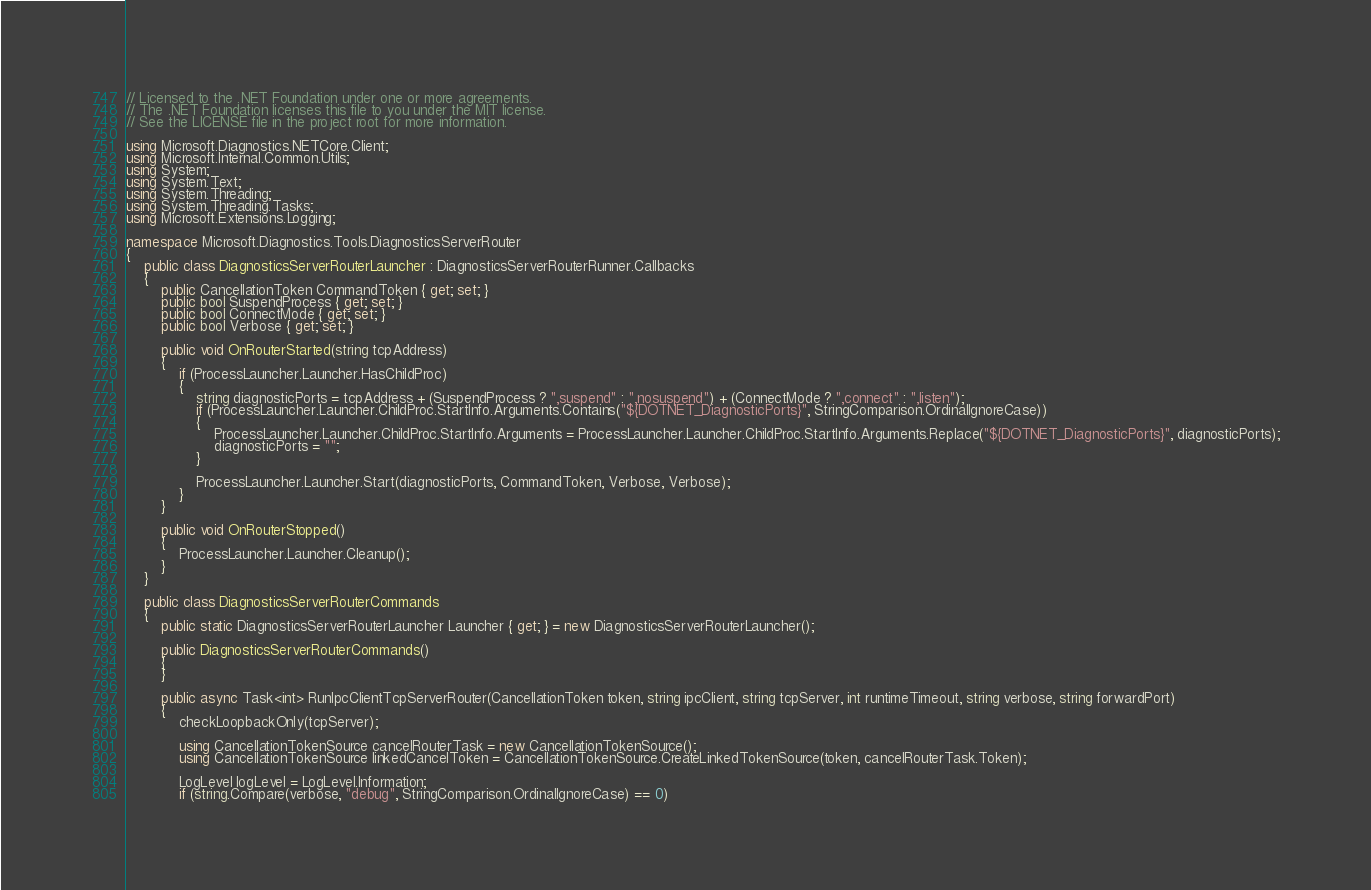<code> <loc_0><loc_0><loc_500><loc_500><_C#_>// Licensed to the .NET Foundation under one or more agreements.
// The .NET Foundation licenses this file to you under the MIT license.
// See the LICENSE file in the project root for more information.

using Microsoft.Diagnostics.NETCore.Client;
using Microsoft.Internal.Common.Utils;
using System;
using System.Text;
using System.Threading;
using System.Threading.Tasks;
using Microsoft.Extensions.Logging;

namespace Microsoft.Diagnostics.Tools.DiagnosticsServerRouter
{
    public class DiagnosticsServerRouterLauncher : DiagnosticsServerRouterRunner.Callbacks
    {
        public CancellationToken CommandToken { get; set; }
        public bool SuspendProcess { get; set; }
        public bool ConnectMode { get; set; }
        public bool Verbose { get; set; }

        public void OnRouterStarted(string tcpAddress)
        {
            if (ProcessLauncher.Launcher.HasChildProc)
            {
                string diagnosticPorts = tcpAddress + (SuspendProcess ? ",suspend" : ",nosuspend") + (ConnectMode ? ",connect" : ",listen");
                if (ProcessLauncher.Launcher.ChildProc.StartInfo.Arguments.Contains("${DOTNET_DiagnosticPorts}", StringComparison.OrdinalIgnoreCase))
                {
                    ProcessLauncher.Launcher.ChildProc.StartInfo.Arguments = ProcessLauncher.Launcher.ChildProc.StartInfo.Arguments.Replace("${DOTNET_DiagnosticPorts}", diagnosticPorts);
                    diagnosticPorts = "";
                }

                ProcessLauncher.Launcher.Start(diagnosticPorts, CommandToken, Verbose, Verbose);
            }
        }

        public void OnRouterStopped()
        {
            ProcessLauncher.Launcher.Cleanup();
        }
    }

    public class DiagnosticsServerRouterCommands
    {
        public static DiagnosticsServerRouterLauncher Launcher { get; } = new DiagnosticsServerRouterLauncher();

        public DiagnosticsServerRouterCommands()
        {
        }

        public async Task<int> RunIpcClientTcpServerRouter(CancellationToken token, string ipcClient, string tcpServer, int runtimeTimeout, string verbose, string forwardPort)
        {
            checkLoopbackOnly(tcpServer);

            using CancellationTokenSource cancelRouterTask = new CancellationTokenSource();
            using CancellationTokenSource linkedCancelToken = CancellationTokenSource.CreateLinkedTokenSource(token, cancelRouterTask.Token);

            LogLevel logLevel = LogLevel.Information;
            if (string.Compare(verbose, "debug", StringComparison.OrdinalIgnoreCase) == 0)</code> 